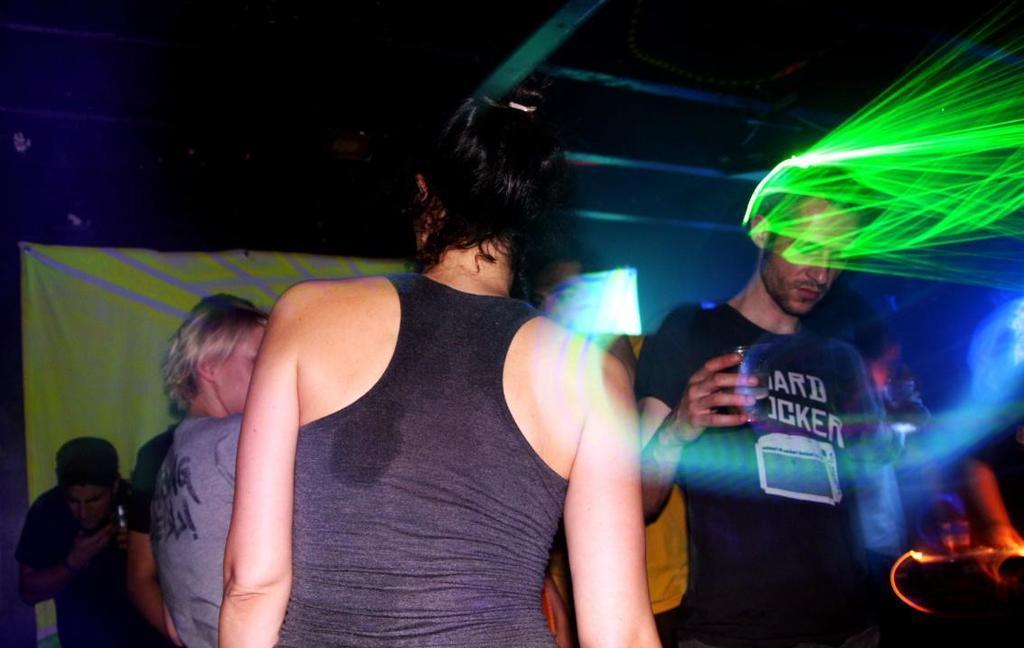Could you give a brief overview of what you see in this image? In the center of the image there is a woman. At the right side of the image there is a man holding a glass in his hand. He is wearing a black color t-shirt. At the background of the image there are persons. 